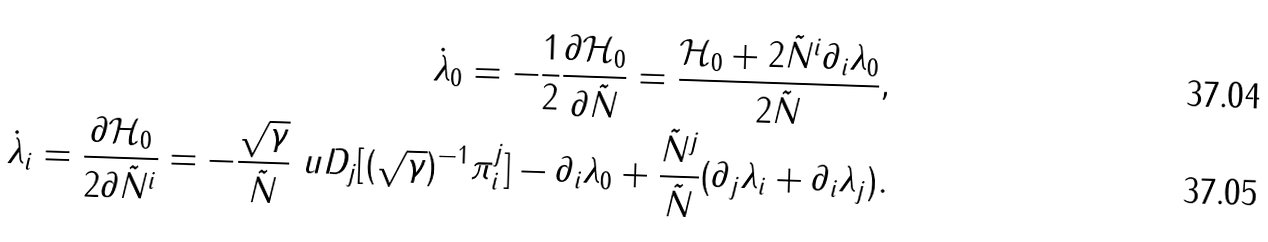Convert formula to latex. <formula><loc_0><loc_0><loc_500><loc_500>\dot { \lambda } _ { 0 } = - \frac { 1 } { 2 } \frac { \partial \mathcal { H } _ { 0 } } { \partial \tilde { N } } = \frac { \mathcal { H } _ { 0 } + 2 \tilde { N } ^ { i } \partial _ { i } \lambda _ { 0 } } { 2 \tilde { N } } , \\ \dot { \lambda } _ { i } = \frac { \partial \mathcal { H } _ { 0 } } { 2 \partial \tilde { N } ^ { i } } = - \frac { \sqrt { \gamma } } { \tilde { N } } \ u D _ { j } [ ( \sqrt { \gamma } ) ^ { - 1 } \pi ^ { j } _ { i } ] - \partial _ { i } \lambda _ { 0 } + \frac { \tilde { N } ^ { j } } { \tilde { N } } ( \partial _ { j } \lambda _ { i } + \partial _ { i } \lambda _ { j } ) .</formula> 